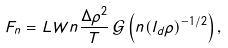Convert formula to latex. <formula><loc_0><loc_0><loc_500><loc_500>F _ { n } = L W n \frac { \Delta \rho ^ { 2 } } { T } \, { \mathcal { G } } \left ( n ( l _ { d } \rho ) ^ { - 1 / 2 } \right ) ,</formula> 